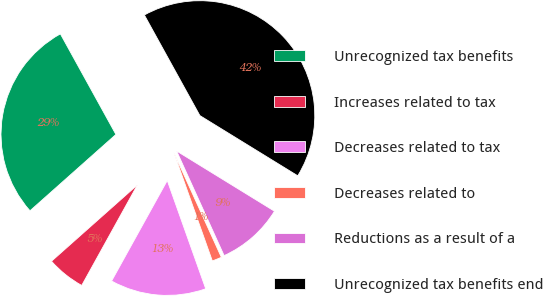<chart> <loc_0><loc_0><loc_500><loc_500><pie_chart><fcel>Unrecognized tax benefits<fcel>Increases related to tax<fcel>Decreases related to tax<fcel>Decreases related to<fcel>Reductions as a result of a<fcel>Unrecognized tax benefits end<nl><fcel>28.53%<fcel>5.39%<fcel>13.48%<fcel>1.35%<fcel>9.44%<fcel>41.8%<nl></chart> 